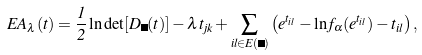<formula> <loc_0><loc_0><loc_500><loc_500>E A _ { \lambda } ( t ) = \frac { 1 } { 2 } \ln \det [ D _ { \Lambda } ( t ) ] - \lambda t _ { j k } + \sum _ { i l \in E ( \Lambda ) } \left ( e ^ { t _ { i l } } - \ln f _ { \alpha } ( e ^ { t _ { i l } } ) - t _ { i l } \right ) ,</formula> 